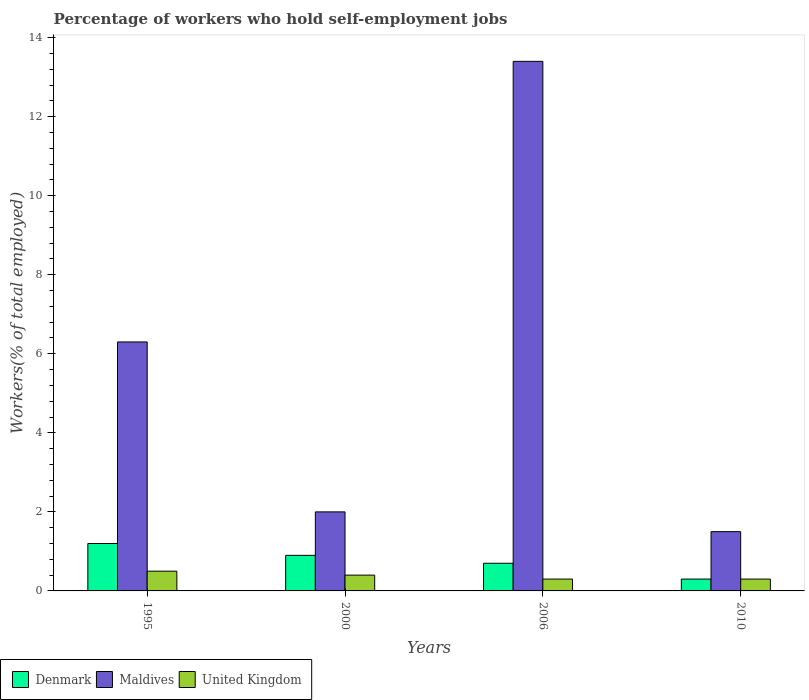How many different coloured bars are there?
Provide a short and direct response. 3. How many groups of bars are there?
Make the answer very short. 4. Are the number of bars on each tick of the X-axis equal?
Offer a very short reply. Yes. How many bars are there on the 4th tick from the left?
Your answer should be very brief. 3. What is the label of the 4th group of bars from the left?
Give a very brief answer. 2010. In how many cases, is the number of bars for a given year not equal to the number of legend labels?
Give a very brief answer. 0. What is the percentage of self-employed workers in Maldives in 2006?
Keep it short and to the point. 13.4. Across all years, what is the maximum percentage of self-employed workers in Maldives?
Give a very brief answer. 13.4. Across all years, what is the minimum percentage of self-employed workers in United Kingdom?
Provide a short and direct response. 0.3. In which year was the percentage of self-employed workers in Maldives minimum?
Provide a short and direct response. 2010. What is the total percentage of self-employed workers in United Kingdom in the graph?
Give a very brief answer. 1.5. What is the difference between the percentage of self-employed workers in United Kingdom in 2000 and that in 2010?
Keep it short and to the point. 0.1. What is the difference between the percentage of self-employed workers in Maldives in 2000 and the percentage of self-employed workers in United Kingdom in 2010?
Your answer should be very brief. 1.7. What is the average percentage of self-employed workers in United Kingdom per year?
Make the answer very short. 0.38. In the year 2006, what is the difference between the percentage of self-employed workers in Denmark and percentage of self-employed workers in United Kingdom?
Your answer should be compact. 0.4. What is the ratio of the percentage of self-employed workers in Denmark in 1995 to that in 2010?
Your answer should be very brief. 4. Is the percentage of self-employed workers in Denmark in 1995 less than that in 2006?
Give a very brief answer. No. Is the difference between the percentage of self-employed workers in Denmark in 2000 and 2006 greater than the difference between the percentage of self-employed workers in United Kingdom in 2000 and 2006?
Give a very brief answer. Yes. What is the difference between the highest and the second highest percentage of self-employed workers in Maldives?
Your response must be concise. 7.1. What is the difference between the highest and the lowest percentage of self-employed workers in United Kingdom?
Keep it short and to the point. 0.2. In how many years, is the percentage of self-employed workers in Denmark greater than the average percentage of self-employed workers in Denmark taken over all years?
Make the answer very short. 2. What does the 2nd bar from the right in 1995 represents?
Provide a succinct answer. Maldives. Is it the case that in every year, the sum of the percentage of self-employed workers in Maldives and percentage of self-employed workers in Denmark is greater than the percentage of self-employed workers in United Kingdom?
Provide a short and direct response. Yes. How many years are there in the graph?
Ensure brevity in your answer.  4. Where does the legend appear in the graph?
Make the answer very short. Bottom left. How many legend labels are there?
Keep it short and to the point. 3. What is the title of the graph?
Offer a terse response. Percentage of workers who hold self-employment jobs. Does "Kyrgyz Republic" appear as one of the legend labels in the graph?
Your response must be concise. No. What is the label or title of the Y-axis?
Make the answer very short. Workers(% of total employed). What is the Workers(% of total employed) of Denmark in 1995?
Your answer should be very brief. 1.2. What is the Workers(% of total employed) in Maldives in 1995?
Your answer should be very brief. 6.3. What is the Workers(% of total employed) of Denmark in 2000?
Your response must be concise. 0.9. What is the Workers(% of total employed) of Maldives in 2000?
Offer a terse response. 2. What is the Workers(% of total employed) of United Kingdom in 2000?
Make the answer very short. 0.4. What is the Workers(% of total employed) in Denmark in 2006?
Provide a short and direct response. 0.7. What is the Workers(% of total employed) in Maldives in 2006?
Provide a succinct answer. 13.4. What is the Workers(% of total employed) in United Kingdom in 2006?
Give a very brief answer. 0.3. What is the Workers(% of total employed) of Denmark in 2010?
Ensure brevity in your answer.  0.3. What is the Workers(% of total employed) in United Kingdom in 2010?
Your answer should be very brief. 0.3. Across all years, what is the maximum Workers(% of total employed) in Denmark?
Your response must be concise. 1.2. Across all years, what is the maximum Workers(% of total employed) of Maldives?
Your answer should be very brief. 13.4. Across all years, what is the maximum Workers(% of total employed) in United Kingdom?
Provide a short and direct response. 0.5. Across all years, what is the minimum Workers(% of total employed) in Denmark?
Your response must be concise. 0.3. Across all years, what is the minimum Workers(% of total employed) of Maldives?
Make the answer very short. 1.5. Across all years, what is the minimum Workers(% of total employed) in United Kingdom?
Keep it short and to the point. 0.3. What is the total Workers(% of total employed) of Maldives in the graph?
Offer a terse response. 23.2. What is the difference between the Workers(% of total employed) of Maldives in 1995 and that in 2000?
Provide a short and direct response. 4.3. What is the difference between the Workers(% of total employed) of United Kingdom in 1995 and that in 2000?
Your answer should be very brief. 0.1. What is the difference between the Workers(% of total employed) in Denmark in 1995 and that in 2010?
Your response must be concise. 0.9. What is the difference between the Workers(% of total employed) of Maldives in 1995 and that in 2010?
Keep it short and to the point. 4.8. What is the difference between the Workers(% of total employed) of United Kingdom in 1995 and that in 2010?
Your response must be concise. 0.2. What is the difference between the Workers(% of total employed) in Denmark in 2000 and that in 2006?
Offer a very short reply. 0.2. What is the difference between the Workers(% of total employed) of United Kingdom in 2000 and that in 2006?
Ensure brevity in your answer.  0.1. What is the difference between the Workers(% of total employed) of Denmark in 2000 and that in 2010?
Offer a very short reply. 0.6. What is the difference between the Workers(% of total employed) of Maldives in 2000 and that in 2010?
Provide a succinct answer. 0.5. What is the difference between the Workers(% of total employed) of United Kingdom in 2000 and that in 2010?
Offer a very short reply. 0.1. What is the difference between the Workers(% of total employed) of Denmark in 2006 and that in 2010?
Give a very brief answer. 0.4. What is the difference between the Workers(% of total employed) in Denmark in 1995 and the Workers(% of total employed) in Maldives in 2000?
Keep it short and to the point. -0.8. What is the difference between the Workers(% of total employed) in Maldives in 1995 and the Workers(% of total employed) in United Kingdom in 2000?
Provide a short and direct response. 5.9. What is the difference between the Workers(% of total employed) in Denmark in 1995 and the Workers(% of total employed) in Maldives in 2006?
Keep it short and to the point. -12.2. What is the difference between the Workers(% of total employed) in Denmark in 1995 and the Workers(% of total employed) in United Kingdom in 2006?
Keep it short and to the point. 0.9. What is the difference between the Workers(% of total employed) of Denmark in 1995 and the Workers(% of total employed) of Maldives in 2010?
Ensure brevity in your answer.  -0.3. What is the difference between the Workers(% of total employed) of Denmark in 1995 and the Workers(% of total employed) of United Kingdom in 2010?
Give a very brief answer. 0.9. What is the difference between the Workers(% of total employed) in Maldives in 1995 and the Workers(% of total employed) in United Kingdom in 2010?
Make the answer very short. 6. What is the difference between the Workers(% of total employed) of Denmark in 2000 and the Workers(% of total employed) of United Kingdom in 2010?
Provide a short and direct response. 0.6. What is the difference between the Workers(% of total employed) in Denmark in 2006 and the Workers(% of total employed) in United Kingdom in 2010?
Your answer should be very brief. 0.4. What is the difference between the Workers(% of total employed) in Maldives in 2006 and the Workers(% of total employed) in United Kingdom in 2010?
Your response must be concise. 13.1. What is the average Workers(% of total employed) in Denmark per year?
Offer a terse response. 0.78. What is the average Workers(% of total employed) in United Kingdom per year?
Give a very brief answer. 0.38. In the year 1995, what is the difference between the Workers(% of total employed) in Denmark and Workers(% of total employed) in Maldives?
Your answer should be very brief. -5.1. In the year 1995, what is the difference between the Workers(% of total employed) of Denmark and Workers(% of total employed) of United Kingdom?
Your response must be concise. 0.7. In the year 1995, what is the difference between the Workers(% of total employed) of Maldives and Workers(% of total employed) of United Kingdom?
Offer a terse response. 5.8. In the year 2006, what is the difference between the Workers(% of total employed) in Denmark and Workers(% of total employed) in United Kingdom?
Make the answer very short. 0.4. In the year 2006, what is the difference between the Workers(% of total employed) of Maldives and Workers(% of total employed) of United Kingdom?
Offer a terse response. 13.1. In the year 2010, what is the difference between the Workers(% of total employed) of Denmark and Workers(% of total employed) of Maldives?
Make the answer very short. -1.2. In the year 2010, what is the difference between the Workers(% of total employed) in Denmark and Workers(% of total employed) in United Kingdom?
Make the answer very short. 0. What is the ratio of the Workers(% of total employed) in Denmark in 1995 to that in 2000?
Provide a succinct answer. 1.33. What is the ratio of the Workers(% of total employed) of Maldives in 1995 to that in 2000?
Your answer should be compact. 3.15. What is the ratio of the Workers(% of total employed) of Denmark in 1995 to that in 2006?
Provide a succinct answer. 1.71. What is the ratio of the Workers(% of total employed) in Maldives in 1995 to that in 2006?
Make the answer very short. 0.47. What is the ratio of the Workers(% of total employed) of United Kingdom in 1995 to that in 2006?
Provide a succinct answer. 1.67. What is the ratio of the Workers(% of total employed) of Denmark in 1995 to that in 2010?
Offer a very short reply. 4. What is the ratio of the Workers(% of total employed) in Maldives in 1995 to that in 2010?
Give a very brief answer. 4.2. What is the ratio of the Workers(% of total employed) of United Kingdom in 1995 to that in 2010?
Offer a very short reply. 1.67. What is the ratio of the Workers(% of total employed) in Denmark in 2000 to that in 2006?
Ensure brevity in your answer.  1.29. What is the ratio of the Workers(% of total employed) of Maldives in 2000 to that in 2006?
Your answer should be compact. 0.15. What is the ratio of the Workers(% of total employed) of Denmark in 2000 to that in 2010?
Your answer should be compact. 3. What is the ratio of the Workers(% of total employed) in United Kingdom in 2000 to that in 2010?
Keep it short and to the point. 1.33. What is the ratio of the Workers(% of total employed) in Denmark in 2006 to that in 2010?
Provide a succinct answer. 2.33. What is the ratio of the Workers(% of total employed) in Maldives in 2006 to that in 2010?
Offer a terse response. 8.93. 